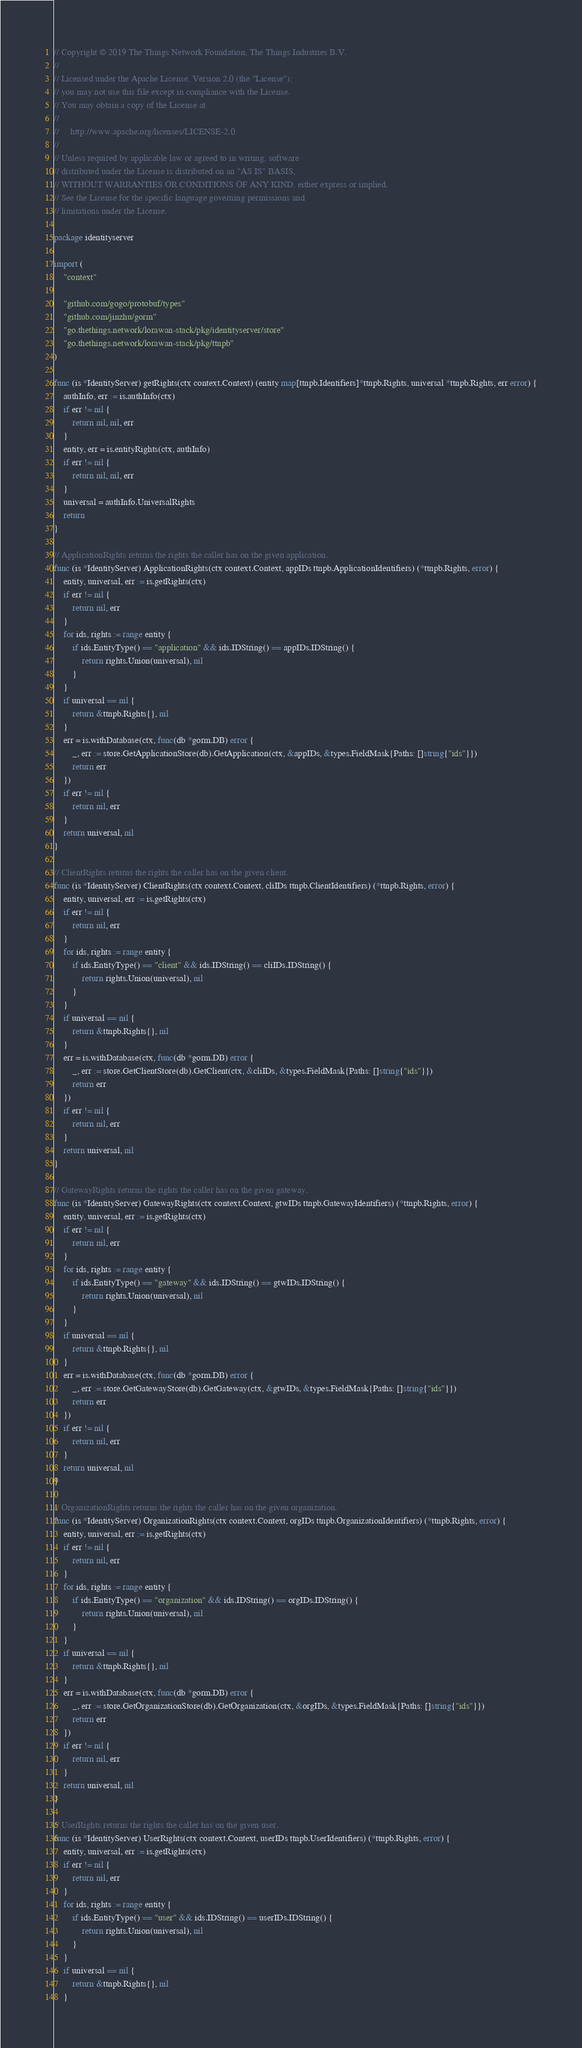Convert code to text. <code><loc_0><loc_0><loc_500><loc_500><_Go_>// Copyright © 2019 The Things Network Foundation, The Things Industries B.V.
//
// Licensed under the Apache License, Version 2.0 (the "License");
// you may not use this file except in compliance with the License.
// You may obtain a copy of the License at
//
//     http://www.apache.org/licenses/LICENSE-2.0
//
// Unless required by applicable law or agreed to in writing, software
// distributed under the License is distributed on an "AS IS" BASIS,
// WITHOUT WARRANTIES OR CONDITIONS OF ANY KIND, either express or implied.
// See the License for the specific language governing permissions and
// limitations under the License.

package identityserver

import (
	"context"

	"github.com/gogo/protobuf/types"
	"github.com/jinzhu/gorm"
	"go.thethings.network/lorawan-stack/pkg/identityserver/store"
	"go.thethings.network/lorawan-stack/pkg/ttnpb"
)

func (is *IdentityServer) getRights(ctx context.Context) (entity map[ttnpb.Identifiers]*ttnpb.Rights, universal *ttnpb.Rights, err error) {
	authInfo, err := is.authInfo(ctx)
	if err != nil {
		return nil, nil, err
	}
	entity, err = is.entityRights(ctx, authInfo)
	if err != nil {
		return nil, nil, err
	}
	universal = authInfo.UniversalRights
	return
}

// ApplicationRights returns the rights the caller has on the given application.
func (is *IdentityServer) ApplicationRights(ctx context.Context, appIDs ttnpb.ApplicationIdentifiers) (*ttnpb.Rights, error) {
	entity, universal, err := is.getRights(ctx)
	if err != nil {
		return nil, err
	}
	for ids, rights := range entity {
		if ids.EntityType() == "application" && ids.IDString() == appIDs.IDString() {
			return rights.Union(universal), nil
		}
	}
	if universal == nil {
		return &ttnpb.Rights{}, nil
	}
	err = is.withDatabase(ctx, func(db *gorm.DB) error {
		_, err := store.GetApplicationStore(db).GetApplication(ctx, &appIDs, &types.FieldMask{Paths: []string{"ids"}})
		return err
	})
	if err != nil {
		return nil, err
	}
	return universal, nil
}

// ClientRights returns the rights the caller has on the given client.
func (is *IdentityServer) ClientRights(ctx context.Context, cliIDs ttnpb.ClientIdentifiers) (*ttnpb.Rights, error) {
	entity, universal, err := is.getRights(ctx)
	if err != nil {
		return nil, err
	}
	for ids, rights := range entity {
		if ids.EntityType() == "client" && ids.IDString() == cliIDs.IDString() {
			return rights.Union(universal), nil
		}
	}
	if universal == nil {
		return &ttnpb.Rights{}, nil
	}
	err = is.withDatabase(ctx, func(db *gorm.DB) error {
		_, err := store.GetClientStore(db).GetClient(ctx, &cliIDs, &types.FieldMask{Paths: []string{"ids"}})
		return err
	})
	if err != nil {
		return nil, err
	}
	return universal, nil
}

// GatewayRights returns the rights the caller has on the given gateway.
func (is *IdentityServer) GatewayRights(ctx context.Context, gtwIDs ttnpb.GatewayIdentifiers) (*ttnpb.Rights, error) {
	entity, universal, err := is.getRights(ctx)
	if err != nil {
		return nil, err
	}
	for ids, rights := range entity {
		if ids.EntityType() == "gateway" && ids.IDString() == gtwIDs.IDString() {
			return rights.Union(universal), nil
		}
	}
	if universal == nil {
		return &ttnpb.Rights{}, nil
	}
	err = is.withDatabase(ctx, func(db *gorm.DB) error {
		_, err := store.GetGatewayStore(db).GetGateway(ctx, &gtwIDs, &types.FieldMask{Paths: []string{"ids"}})
		return err
	})
	if err != nil {
		return nil, err
	}
	return universal, nil
}

// OrganizationRights returns the rights the caller has on the given organization.
func (is *IdentityServer) OrganizationRights(ctx context.Context, orgIDs ttnpb.OrganizationIdentifiers) (*ttnpb.Rights, error) {
	entity, universal, err := is.getRights(ctx)
	if err != nil {
		return nil, err
	}
	for ids, rights := range entity {
		if ids.EntityType() == "organization" && ids.IDString() == orgIDs.IDString() {
			return rights.Union(universal), nil
		}
	}
	if universal == nil {
		return &ttnpb.Rights{}, nil
	}
	err = is.withDatabase(ctx, func(db *gorm.DB) error {
		_, err := store.GetOrganizationStore(db).GetOrganization(ctx, &orgIDs, &types.FieldMask{Paths: []string{"ids"}})
		return err
	})
	if err != nil {
		return nil, err
	}
	return universal, nil
}

// UserRights returns the rights the caller has on the given user.
func (is *IdentityServer) UserRights(ctx context.Context, userIDs ttnpb.UserIdentifiers) (*ttnpb.Rights, error) {
	entity, universal, err := is.getRights(ctx)
	if err != nil {
		return nil, err
	}
	for ids, rights := range entity {
		if ids.EntityType() == "user" && ids.IDString() == userIDs.IDString() {
			return rights.Union(universal), nil
		}
	}
	if universal == nil {
		return &ttnpb.Rights{}, nil
	}</code> 